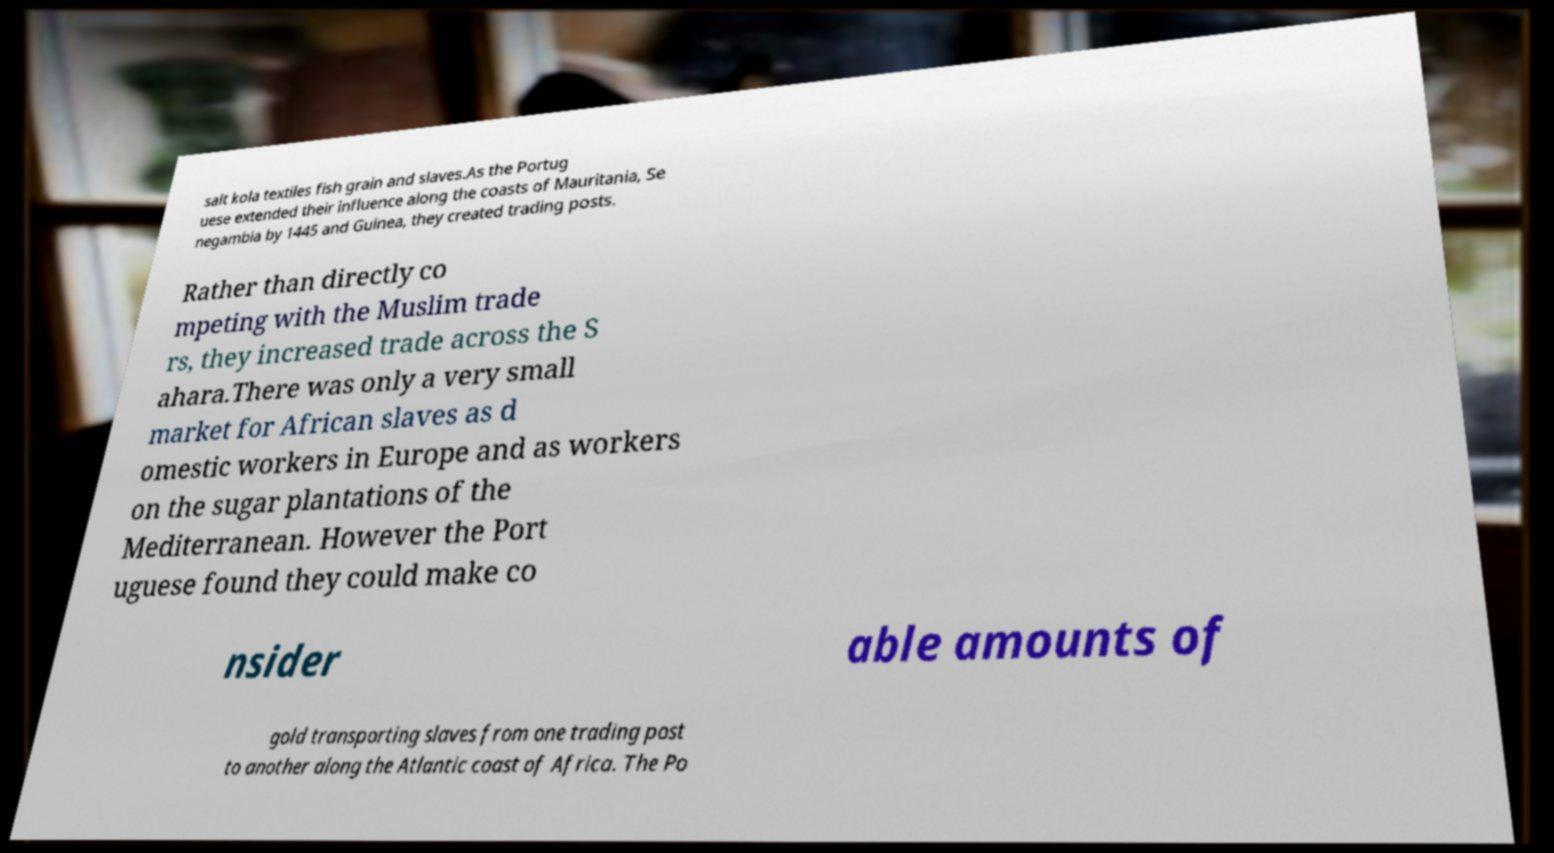Please identify and transcribe the text found in this image. salt kola textiles fish grain and slaves.As the Portug uese extended their influence along the coasts of Mauritania, Se negambia by 1445 and Guinea, they created trading posts. Rather than directly co mpeting with the Muslim trade rs, they increased trade across the S ahara.There was only a very small market for African slaves as d omestic workers in Europe and as workers on the sugar plantations of the Mediterranean. However the Port uguese found they could make co nsider able amounts of gold transporting slaves from one trading post to another along the Atlantic coast of Africa. The Po 